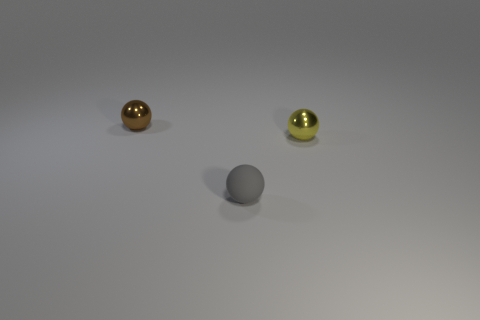Add 1 yellow balls. How many objects exist? 4 Add 3 matte balls. How many matte balls are left? 4 Add 2 yellow objects. How many yellow objects exist? 3 Subtract 0 cyan cubes. How many objects are left? 3 Subtract all brown metal balls. Subtract all small brown objects. How many objects are left? 1 